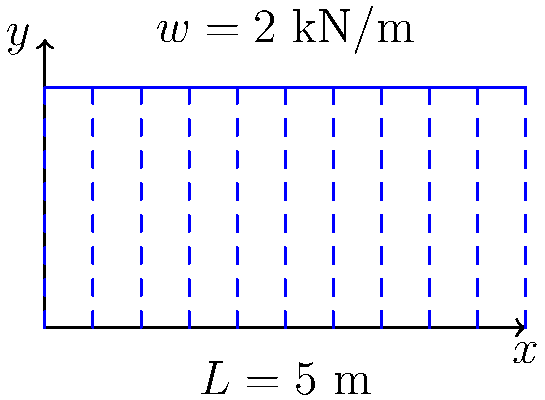A simply supported beam of length $L = 5$ m is subjected to a uniformly distributed load of $w = 2$ kN/m along its entire length, similar to the setup for a xylophone in your music classroom. Determine the maximum bending moment in the beam. How might understanding this concept help in designing a sturdy music stand for your students? Let's approach this step-by-step:

1) For a simply supported beam with a uniformly distributed load, the maximum bending moment occurs at the center of the beam.

2) The formula for the maximum bending moment in this case is:

   $$M_{max} = \frac{wL^2}{8}$$

   Where:
   $w$ is the uniformly distributed load
   $L$ is the length of the beam

3) We're given:
   $w = 2$ kN/m
   $L = 5$ m

4) Let's substitute these values into our formula:

   $$M_{max} = \frac{2 \cdot 5^2}{8} = \frac{2 \cdot 25}{8} = \frac{50}{8} = 6.25 \text{ kN·m}$$

5) Therefore, the maximum bending moment in the beam is 6.25 kN·m.

Understanding this concept can help in designing a sturdy music stand by ensuring that the stand can withstand the weight of heavy music books or instruments without bending or breaking. Just as the beam must support a distributed load, a music stand must support the weight of materials placed on it, and understanding the principles of bending moments can guide the design process to create a stand that is both functional and durable for your music classroom.
Answer: 6.25 kN·m 